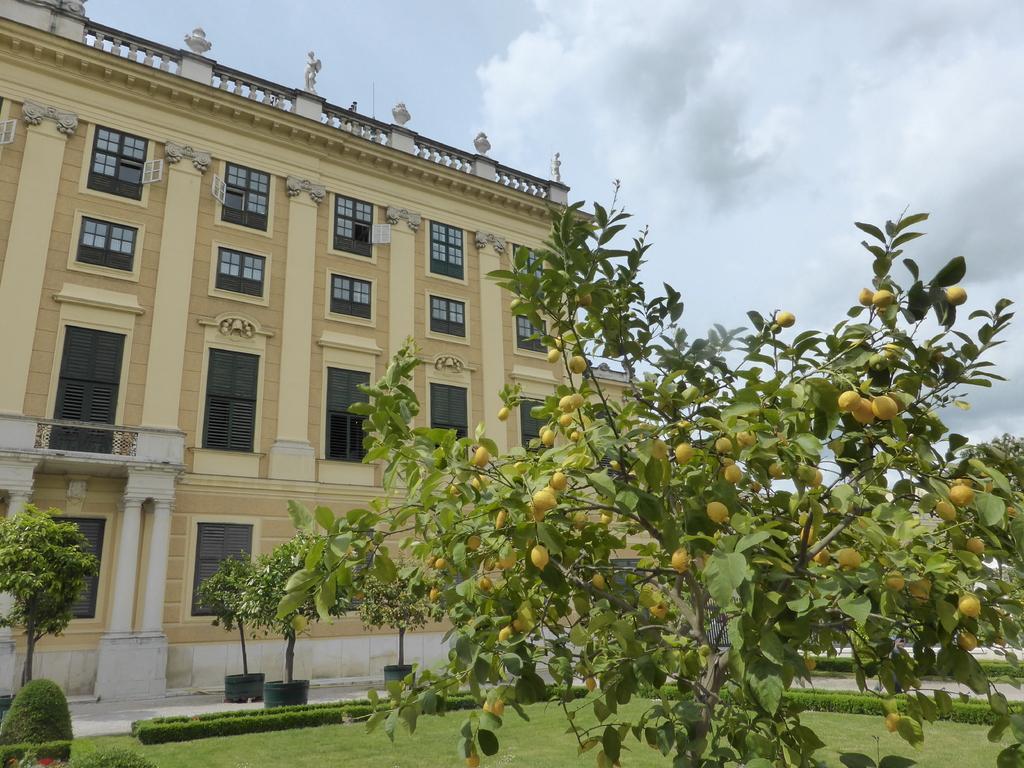Please provide a concise description of this image. In front of the image there is a lemon tree with lemons on it, behind the tree there are bushes, plants, trees and a building, at the top of the image there are clouds in the sky. 